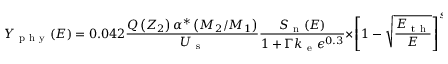<formula> <loc_0><loc_0><loc_500><loc_500>Y _ { p h y } ( E ) = 0 . 0 4 2 \frac { Q \left ( Z _ { 2 } \right ) \alpha ^ { * } \left ( M _ { 2 } / M _ { 1 } \right ) } { U _ { s } } \frac { S _ { n } ( E ) } { 1 + \Gamma k _ { e } \epsilon ^ { 0 . 3 } } \times { \left [ 1 - \sqrt { \frac { E _ { t h } } { E } } \right ] ^ { s } }</formula> 